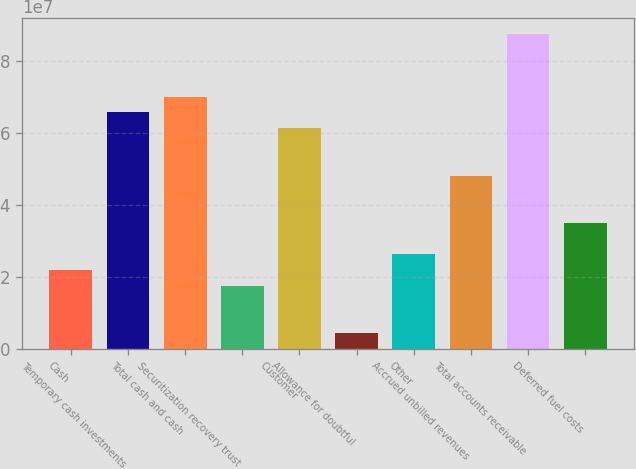Convert chart. <chart><loc_0><loc_0><loc_500><loc_500><bar_chart><fcel>Cash<fcel>Temporary cash investments<fcel>Total cash and cash<fcel>Securitization recovery trust<fcel>Customer<fcel>Allowance for doubtful<fcel>Other<fcel>Accrued unbilled revenues<fcel>Total accounts receivable<fcel>Deferred fuel costs<nl><fcel>2.19371e+07<fcel>6.57917e+07<fcel>7.01771e+07<fcel>1.75517e+07<fcel>6.14062e+07<fcel>4.39531e+06<fcel>2.63226e+07<fcel>4.82499e+07<fcel>8.7719e+07<fcel>3.50935e+07<nl></chart> 